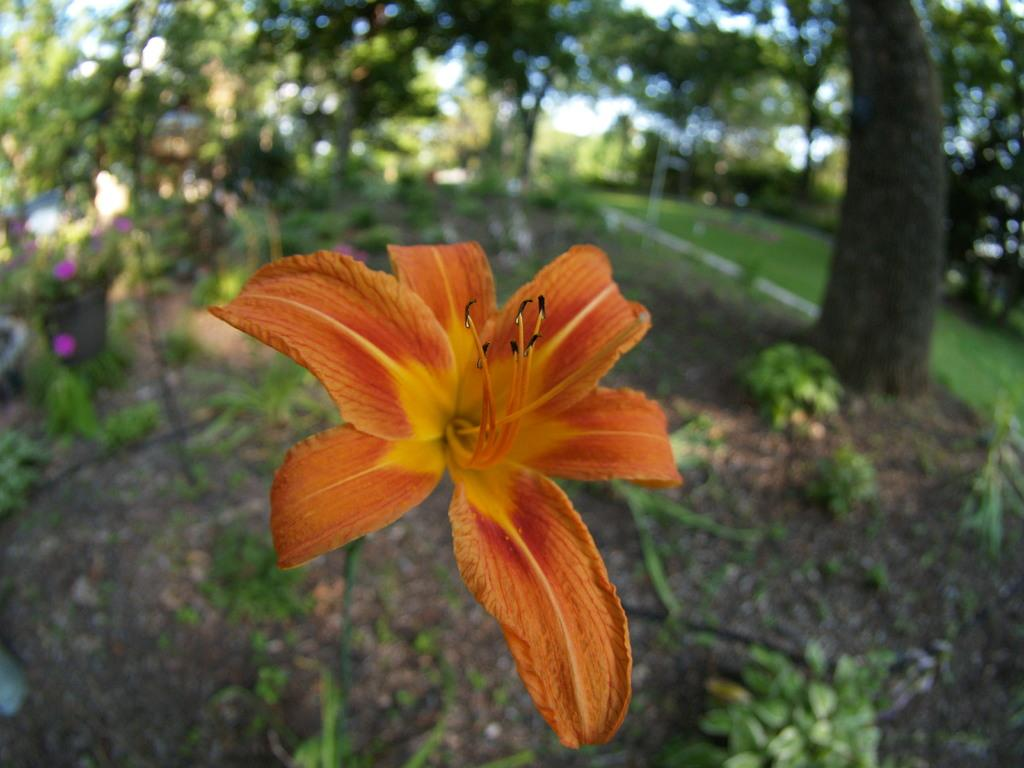What type of flower is in the image? There is an orange color flower in the image. To which plant does the flower belong? The flower belongs to a plant. What can be seen in the background of the image? There are trees, plants, grass, and the sky visible in the background of the image. What type of health advice can be seen in the image? There is no health advice present in the image; it features an orange color flower and its background. 